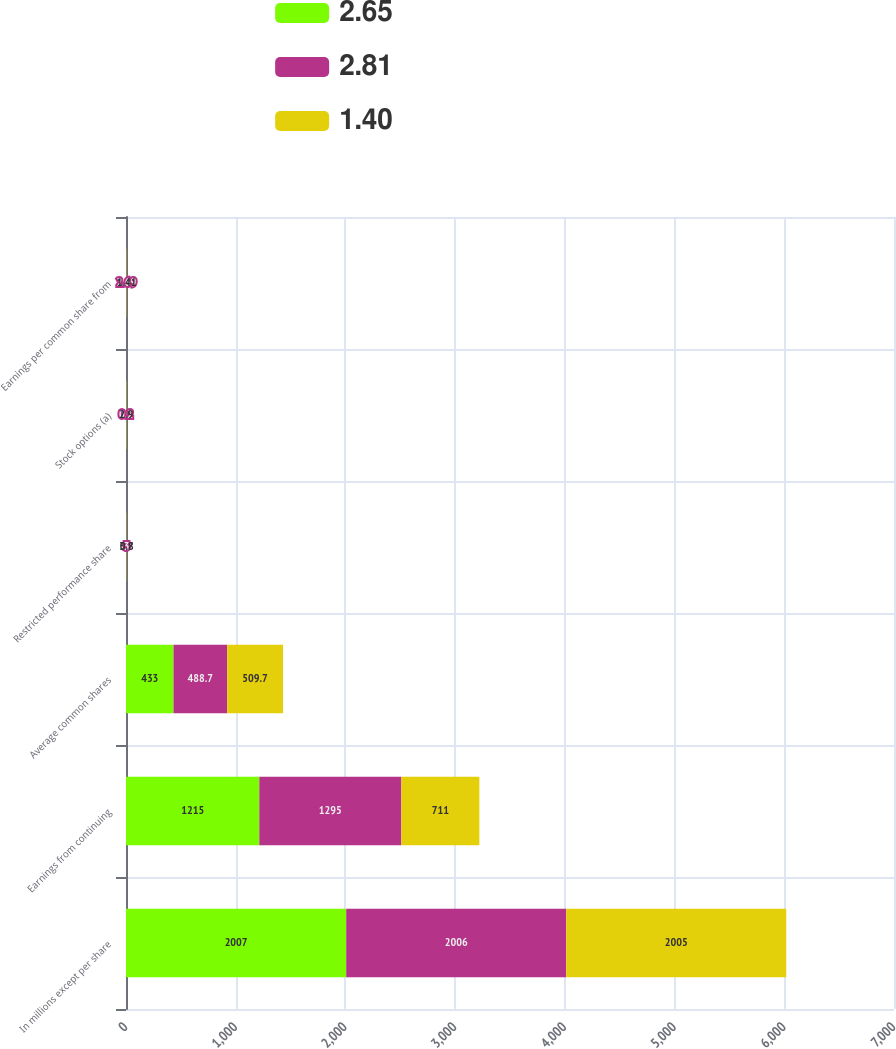Convert chart to OTSL. <chart><loc_0><loc_0><loc_500><loc_500><stacked_bar_chart><ecel><fcel>In millions except per share<fcel>Earnings from continuing<fcel>Average common shares<fcel>Restricted performance share<fcel>Stock options (a)<fcel>Earnings per common share from<nl><fcel>2.65<fcel>2007<fcel>1215<fcel>433<fcel>3.7<fcel>0.4<fcel>2.83<nl><fcel>2.81<fcel>2006<fcel>1295<fcel>488.7<fcel>3<fcel>0.2<fcel>2.69<nl><fcel>1.4<fcel>2005<fcel>711<fcel>509.7<fcel>0.8<fcel>2.9<fcel>1.41<nl></chart> 